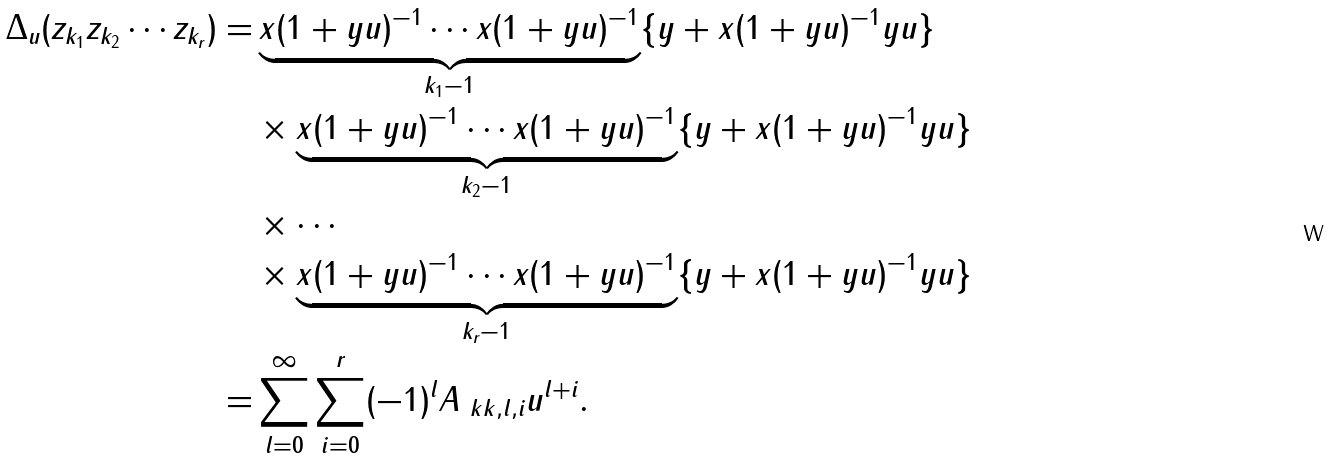<formula> <loc_0><loc_0><loc_500><loc_500>\Delta _ { u } ( z _ { k _ { 1 } } z _ { k _ { 2 } } \cdots z _ { k _ { r } } ) = & \underbrace { x ( 1 + y u ) ^ { - 1 } \cdots x ( 1 + y u ) ^ { - 1 } } _ { k _ { 1 } - 1 } \{ y + x ( 1 + y u ) ^ { - 1 } y u \} \\ & \times \underbrace { x ( 1 + y u ) ^ { - 1 } \cdots x ( 1 + y u ) ^ { - 1 } } _ { k _ { 2 } - 1 } \{ y + x ( 1 + y u ) ^ { - 1 } y u \} \\ & \times \cdots \\ & \times \underbrace { x ( 1 + y u ) ^ { - 1 } \cdots x ( 1 + y u ) ^ { - 1 } } _ { k _ { r } - 1 } \{ y + x ( 1 + y u ) ^ { - 1 } y u \} \\ = & \sum _ { l = 0 } ^ { \infty } \sum _ { i = 0 } ^ { r } ( - 1 ) ^ { l } A _ { \ k k , l , i } u ^ { l + i } .</formula> 